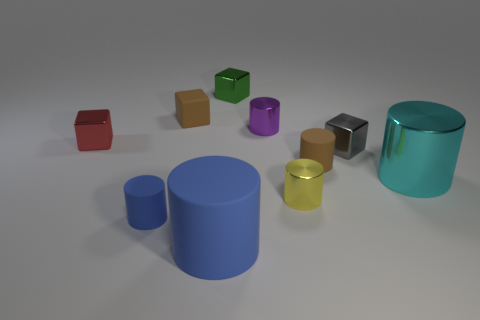The brown thing that is behind the small gray block has what shape?
Your answer should be very brief. Cube. There is a matte object to the left of the small brown thing left of the thing that is in front of the tiny blue rubber thing; what is its color?
Provide a succinct answer. Blue. Are the red object and the gray object made of the same material?
Your answer should be compact. Yes. What number of blue things are either metallic spheres or big matte cylinders?
Give a very brief answer. 1. There is a red cube; how many small rubber cubes are on the left side of it?
Offer a terse response. 0. Is the number of small green objects greater than the number of big brown matte cubes?
Give a very brief answer. Yes. What shape is the matte object behind the cylinder that is behind the gray cube?
Ensure brevity in your answer.  Cube. Is the big matte thing the same color as the rubber cube?
Your answer should be very brief. No. Are there more tiny blue rubber cylinders behind the small gray metal object than yellow objects?
Give a very brief answer. No. There is a blue matte cylinder that is on the right side of the tiny blue object; what number of small gray things are in front of it?
Provide a succinct answer. 0. 